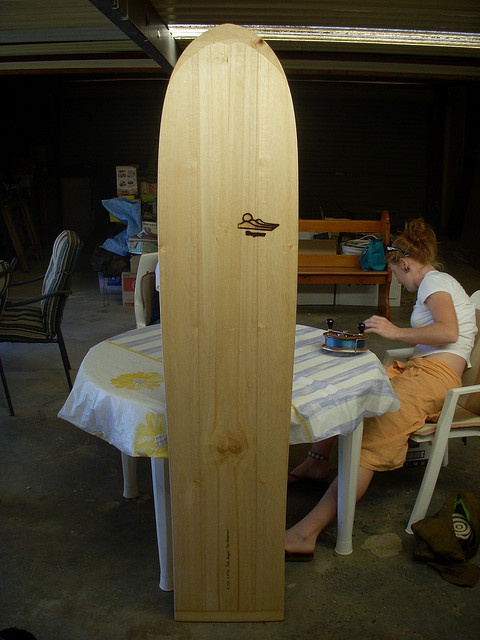Describe the objects in this image and their specific colors. I can see surfboard in black, olive, and tan tones, dining table in black, darkgray, and gray tones, people in black, olive, gray, and maroon tones, bench in black, maroon, olive, and gray tones, and handbag in black, darkgreen, and olive tones in this image. 